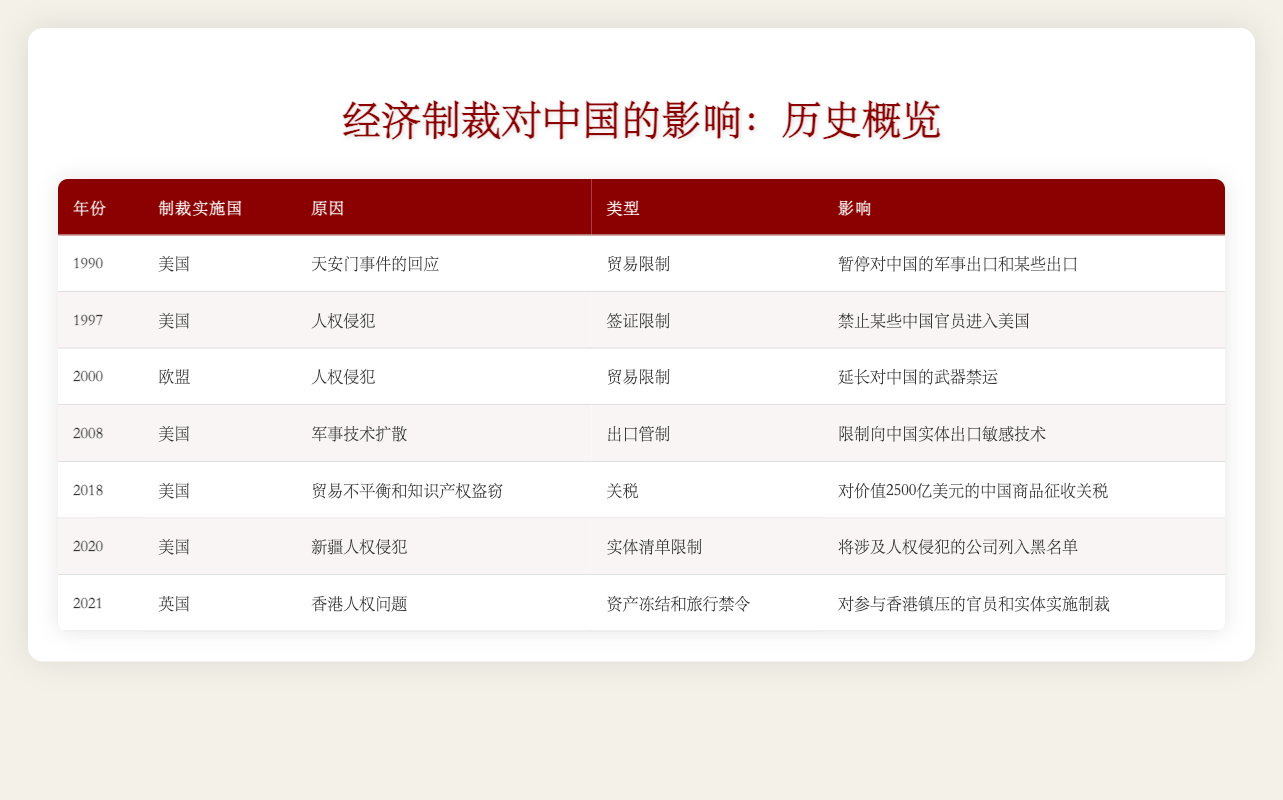What year did the United States impose sanctions in response to the Tiananmen Square Massacre? The table indicates that the United States imposed sanctions in 1990 due to the Tiananmen Square Massacre.
Answer: 1990 Which country extended the arms embargo against China in 2000? According to the table, the European Union extended the arms embargo against China in 2000.
Answer: European Union How many times did the United States impose sanctions on China between 1990 and 2021? By reviewing the table, the United States imposed sanctions on China a total of five times from 1990 to 2021 (in 1990, 1997, 2008, 2018, and 2020).
Answer: 5 What were the reasons for the sanctions imposed in the year 2018? The table shows that the sanctions imposed in 2018 by the United States were attributed to trade imbalances and intellectual property theft.
Answer: Trade imbalances and intellectual property theft Was there any sanction imposed by the United Kingdom in relation to human rights issues? Yes, the table indicates that in 2021, the United Kingdom imposed sanctions due to human rights issues in Hong Kong.
Answer: Yes Which sanction had the most significant economic impact in terms of value? The 2018 sanctions involving tariffs on $250 billion worth of Chinese goods had the most considerable economic impact according to the table.
Answer: 2018 sanctions What is the average year in which sanctions were imposed based on this data? The years of sanctions imposed in the table are 1990, 1997, 2000, 2008, 2018, 2020, and 2021. Adding these years gives a total of 1990 + 1997 + 2000 + 2008 + 2018 + 2020 + 2021 = 13934, and then dividing by 7 gives an average year of approximately 1990.57, which rounds down to 1991 as the statistical result.
Answer: 1991 Which country imposed sanctions for military technology proliferation? The table specifies that the United States imposed sanctions for military technology proliferation in 2008.
Answer: United States How many of the sanctions in the table were specifically related to human rights issues? Looking through the table, there were three sanctions explicitly related to human rights issues: 1997 (U.S. on human rights violations), 2020 (U.S. on Xinjiang), and 2021 (U.K. on Hong Kong).
Answer: 3 Which type of sanction was most commonly imposed by the United States on China? The table reveals that the most common type of sanction imposed by the United States on China was trade restrictions, seen in the years 1990, 2000, and 2018.
Answer: Trade restrictions 